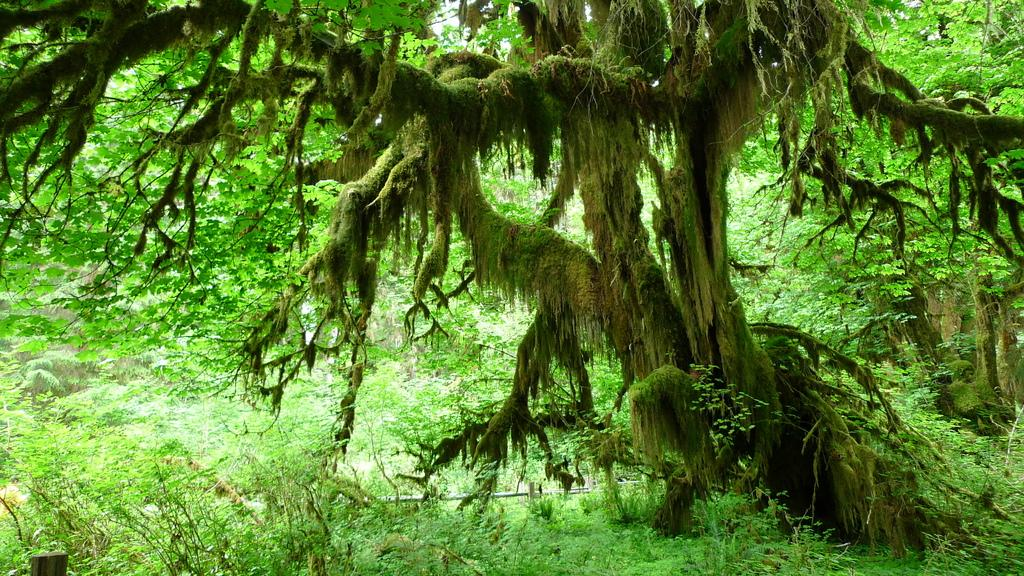What type of vegetation can be seen in the image? There are trees in the image. What is the color of the trees in the image? The trees are green in color. Where is the route for the upcoming baseball game located in the image? There is no route or baseball game present in the image; it only features trees. What type of toys can be seen scattered around the trees in the image? There are no toys present in the image; it only features trees. 